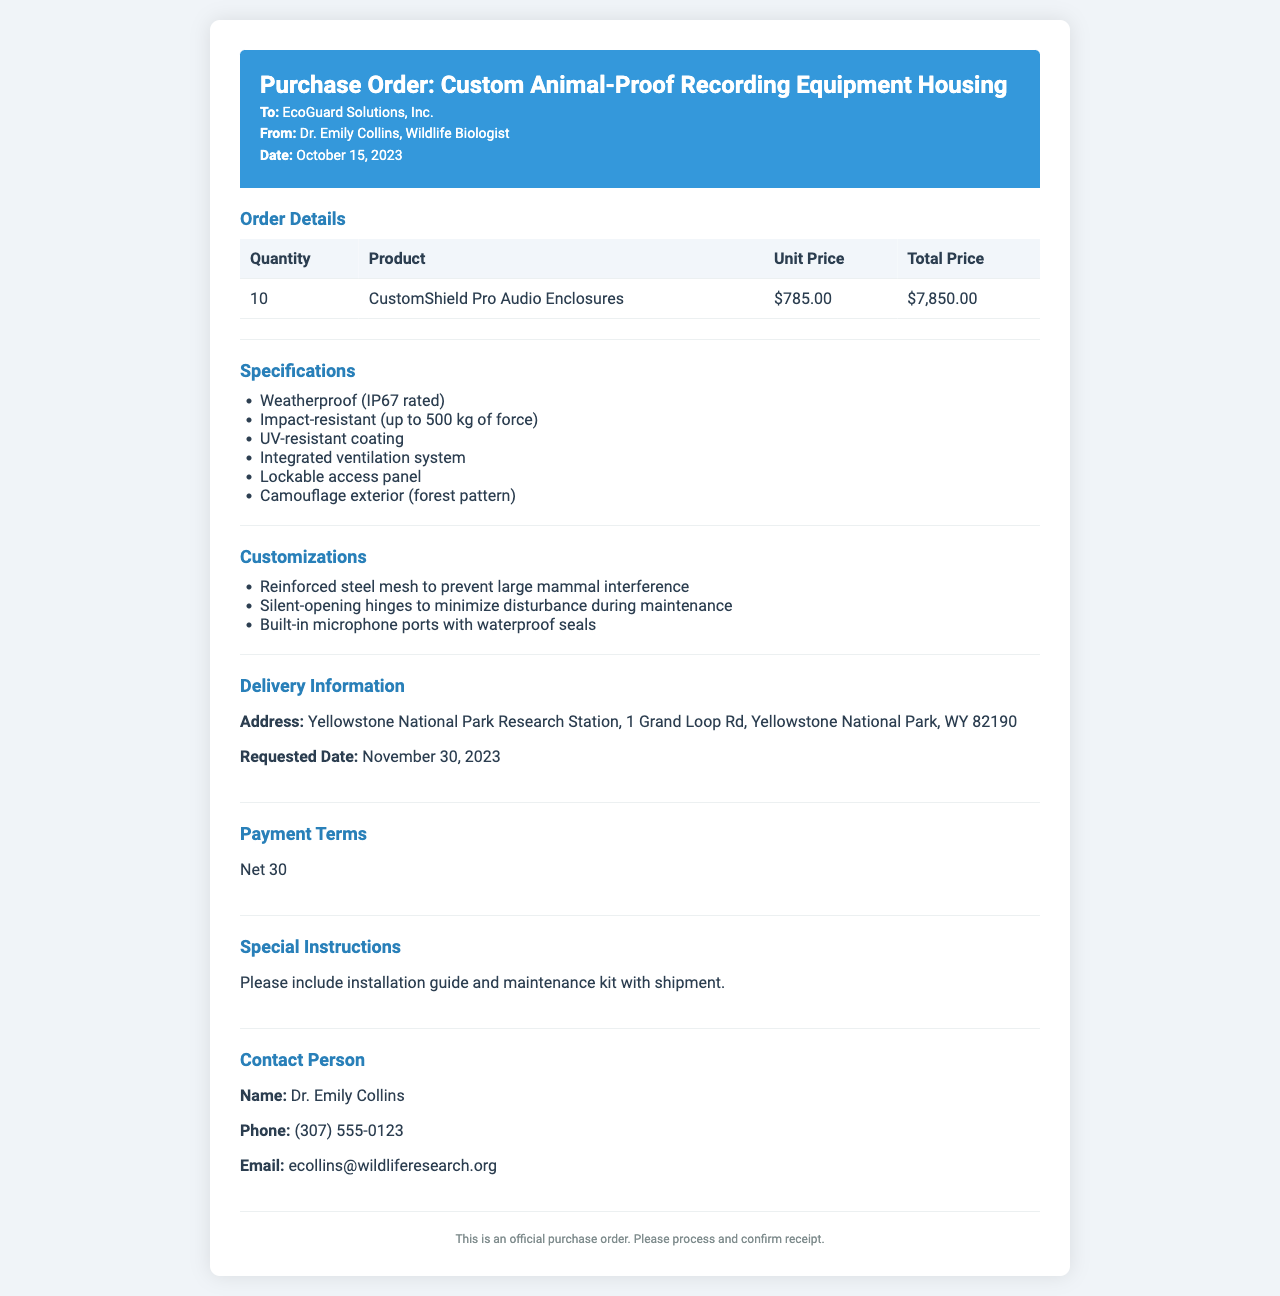What is the date of the purchase order? The date of the purchase order is stated in the document as October 15, 2023.
Answer: October 15, 2023 Who is the contact person for the order? The contact person is listed in the document under the contact section.
Answer: Dr. Emily Collins What is the unit price of the CustomShield Pro Audio Enclosures? The unit price is provided in the order details section of the document.
Answer: $785.00 What type of coating do the enclosures have? The coating type is specified in the specifications section as UV-resistant.
Answer: UV-resistant How many enclosures are being ordered? The quantity of enclosures is stated in the order details section.
Answer: 10 What is the total price for the order? The total price is calculated based on the quantity and unit price in the order details.
Answer: $7,850.00 What is the payment term specified in the document? The payment terms are mentioned clearly in the payment terms section.
Answer: Net 30 What special instruction is included with the purchase order? The special instructions are outlined in their own section of the document.
Answer: Please include installation guide and maintenance kit with shipment When is the requested delivery date? The requested delivery date is mentioned in the delivery information section of the document.
Answer: November 30, 2023 